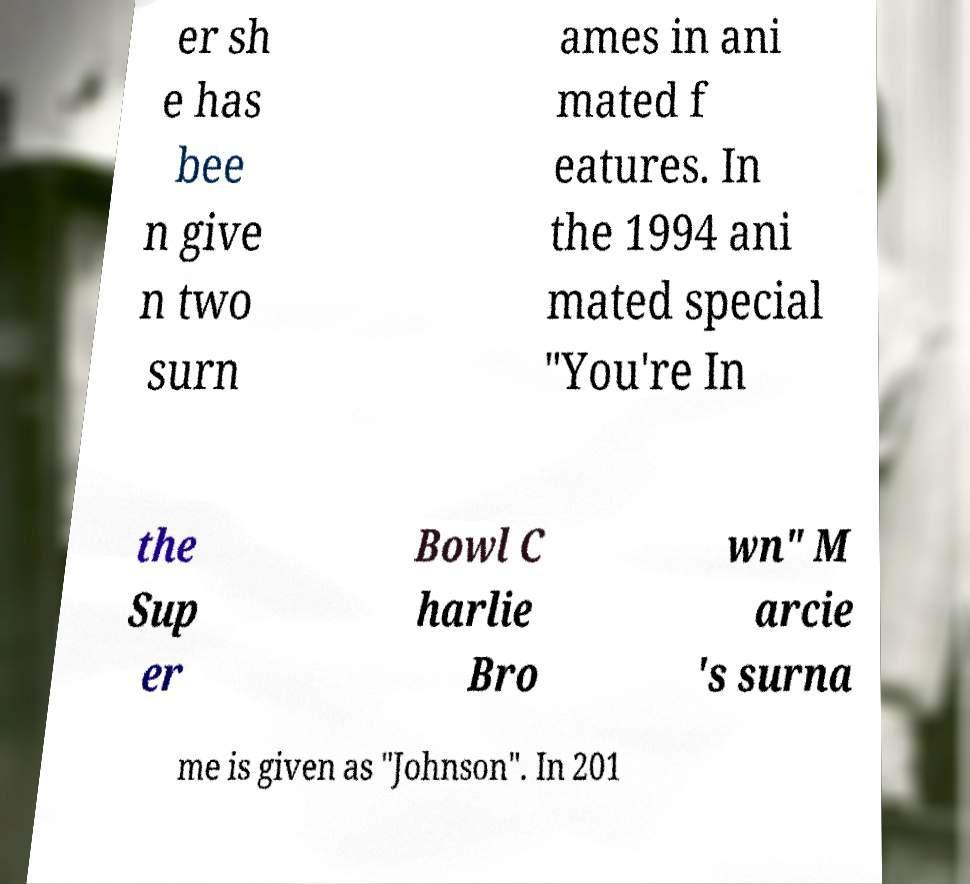What messages or text are displayed in this image? I need them in a readable, typed format. er sh e has bee n give n two surn ames in ani mated f eatures. In the 1994 ani mated special "You're In the Sup er Bowl C harlie Bro wn" M arcie 's surna me is given as "Johnson". In 201 